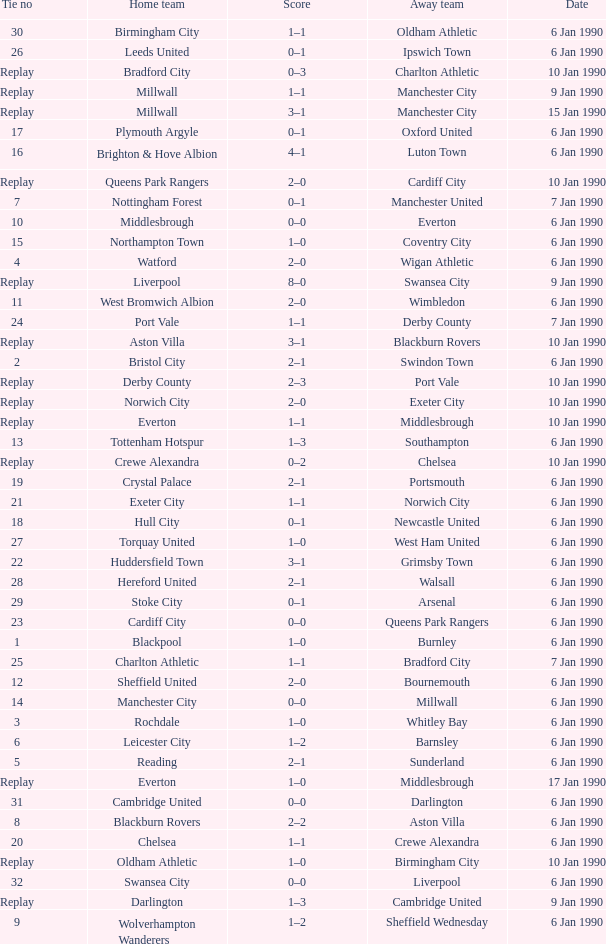What is the score of the game against away team exeter city on 10 jan 1990? 2–0. 